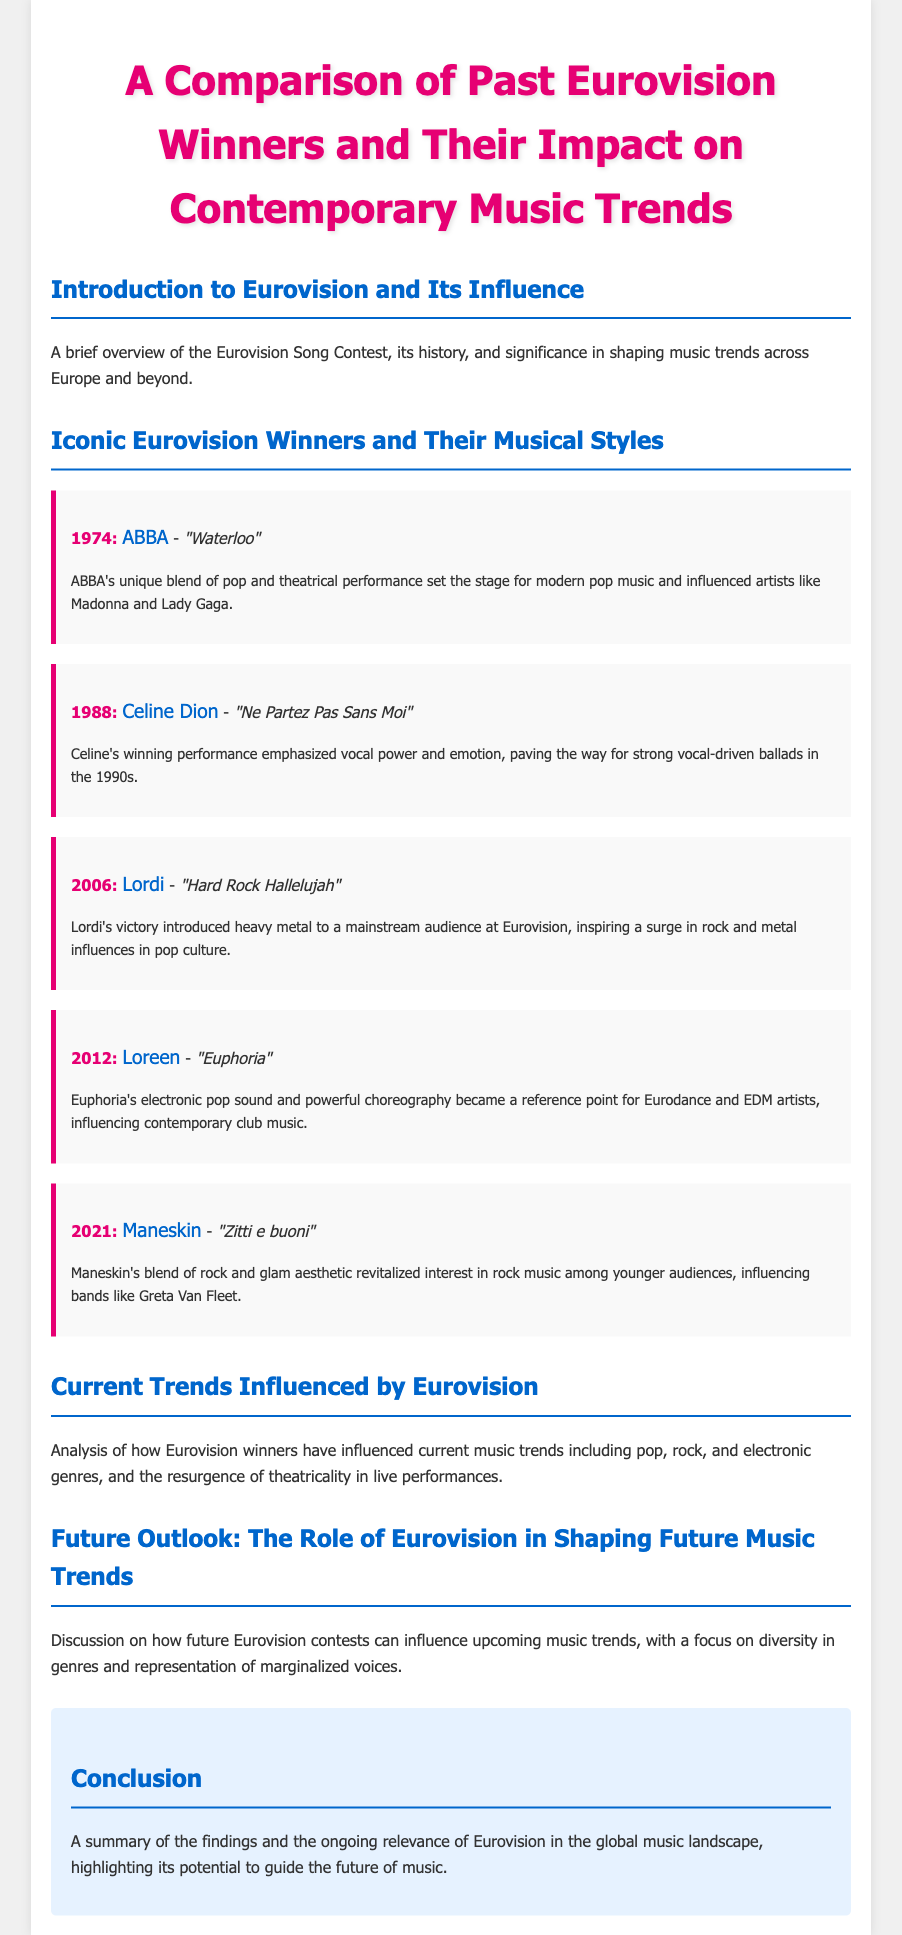What year did ABBA win Eurovision? ABBA won Eurovision in 1974.
Answer: 1974 Which song did Celine Dion perform to win Eurovision? Celine Dion performed “Ne Partez Pas Sans Moi” to win in 1988.
Answer: "Ne Partez Pas Sans Moi" What genre did Lordi introduce to Eurovision? Lordi introduced heavy metal to Eurovision with their 2006 win.
Answer: Heavy metal What is the title of Loreen's winning song? Loreen's winning song is “Euphoria,” which she performed in 2012.
Answer: "Euphoria" Which band revitalized interest in rock music after their Eurovision win? Maneskin revitalized interest in rock music after their win in 2021.
Answer: Maneskin What type of performance style has seen a resurgence due to Eurovision winners? Theatricality in live performances has seen a resurgence.
Answer: Theatricality How many Eurovision winners are discussed in the document? The document discusses five Eurovision winners.
Answer: Five Which music trend has been influenced by Loreen’s performance? Loreen's performance influenced Eurodance and EDM artists.
Answer: Eurodance and EDM What does the conclusion highlight about Eurovision? The conclusion highlights Eurovision's ongoing relevance in the global music landscape.
Answer: Ongoing relevance 